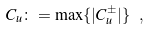Convert formula to latex. <formula><loc_0><loc_0><loc_500><loc_500>C _ { u } \colon = \max \{ | C ^ { \pm } _ { u } | \} \ ,</formula> 